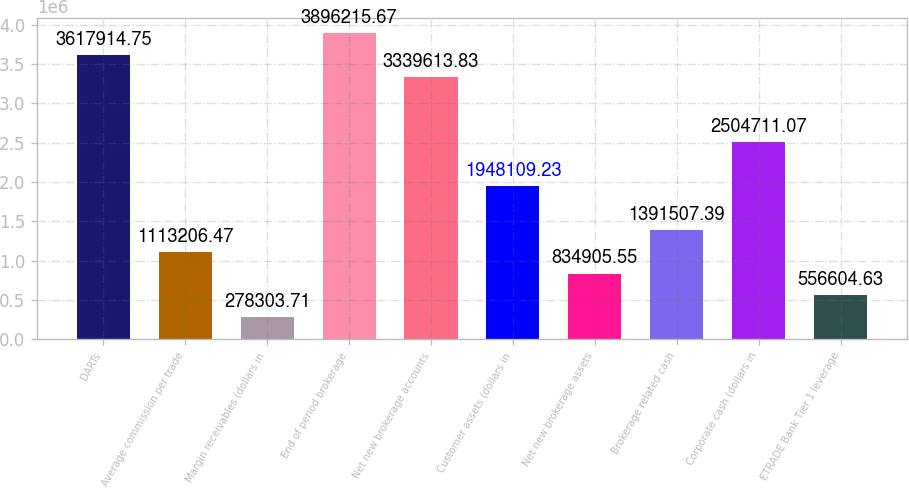<chart> <loc_0><loc_0><loc_500><loc_500><bar_chart><fcel>DARTs<fcel>Average commission per trade<fcel>Margin receivables (dollars in<fcel>End of period brokerage<fcel>Net new brokerage accounts<fcel>Customer assets (dollars in<fcel>Net new brokerage assets<fcel>Brokerage related cash<fcel>Corporate cash (dollars in<fcel>ETRADE Bank Tier 1 leverage<nl><fcel>3.61791e+06<fcel>1.11321e+06<fcel>278304<fcel>3.89622e+06<fcel>3.33961e+06<fcel>1.94811e+06<fcel>834906<fcel>1.39151e+06<fcel>2.50471e+06<fcel>556605<nl></chart> 